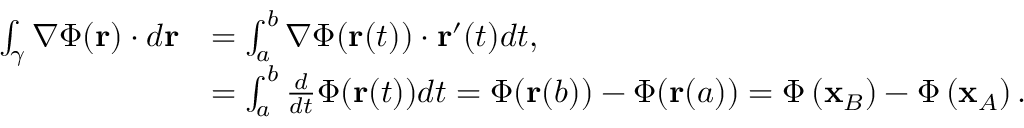<formula> <loc_0><loc_0><loc_500><loc_500>{ \begin{array} { r l } { \int _ { \gamma } \nabla \Phi ( r ) \cdot d r } & { = \int _ { a } ^ { b } \nabla \Phi ( r ( t ) ) \cdot r ^ { \prime } ( t ) d t , } \\ & { = \int _ { a } ^ { b } { \frac { d } { d t } } \Phi ( r ( t ) ) d t = \Phi ( r ( b ) ) - \Phi ( r ( a ) ) = \Phi \left ( x _ { B } \right ) - \Phi \left ( x _ { A } \right ) . } \end{array} }</formula> 